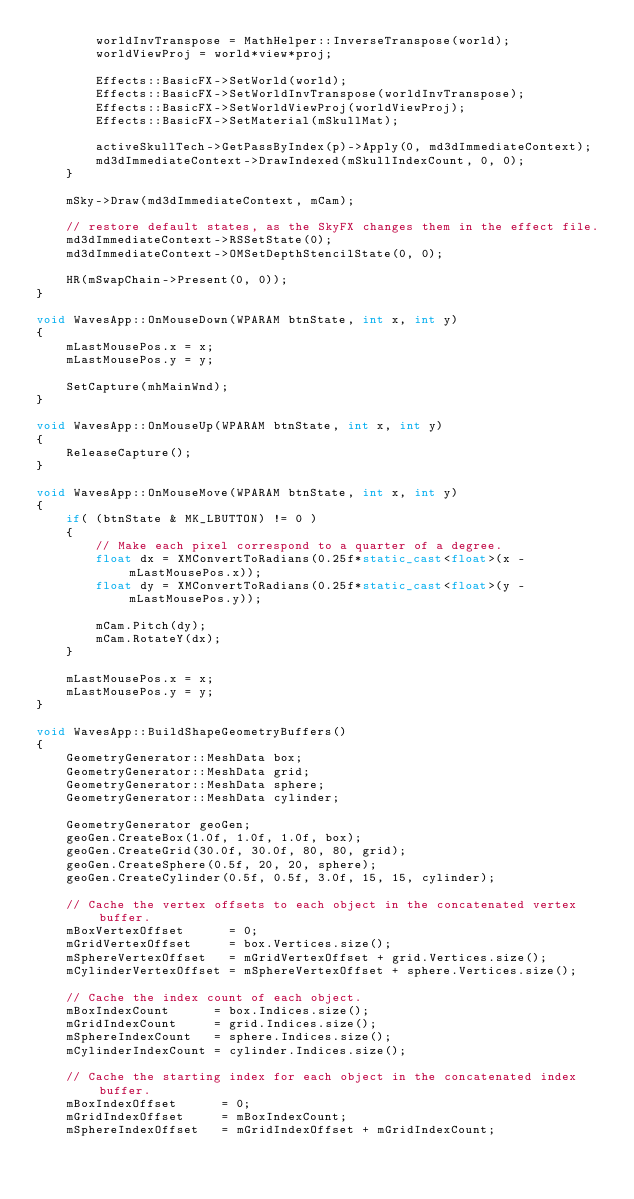<code> <loc_0><loc_0><loc_500><loc_500><_C++_>		worldInvTranspose = MathHelper::InverseTranspose(world);
		worldViewProj = world*view*proj;

		Effects::BasicFX->SetWorld(world);
		Effects::BasicFX->SetWorldInvTranspose(worldInvTranspose);
		Effects::BasicFX->SetWorldViewProj(worldViewProj);
		Effects::BasicFX->SetMaterial(mSkullMat);

		activeSkullTech->GetPassByIndex(p)->Apply(0, md3dImmediateContext);
		md3dImmediateContext->DrawIndexed(mSkullIndexCount, 0, 0);
	}

	mSky->Draw(md3dImmediateContext, mCam);

	// restore default states, as the SkyFX changes them in the effect file.
	md3dImmediateContext->RSSetState(0);
	md3dImmediateContext->OMSetDepthStencilState(0, 0);

	HR(mSwapChain->Present(0, 0));
}

void WavesApp::OnMouseDown(WPARAM btnState, int x, int y)
{
	mLastMousePos.x = x;
	mLastMousePos.y = y;

	SetCapture(mhMainWnd);
}

void WavesApp::OnMouseUp(WPARAM btnState, int x, int y)
{
	ReleaseCapture();
}

void WavesApp::OnMouseMove(WPARAM btnState, int x, int y)
{
	if( (btnState & MK_LBUTTON) != 0 )
	{
		// Make each pixel correspond to a quarter of a degree.
		float dx = XMConvertToRadians(0.25f*static_cast<float>(x - mLastMousePos.x));
		float dy = XMConvertToRadians(0.25f*static_cast<float>(y - mLastMousePos.y));

		mCam.Pitch(dy);
		mCam.RotateY(dx);
	}

	mLastMousePos.x = x;
	mLastMousePos.y = y;
}

void WavesApp::BuildShapeGeometryBuffers()
{
	GeometryGenerator::MeshData box;
	GeometryGenerator::MeshData grid;
	GeometryGenerator::MeshData sphere;
	GeometryGenerator::MeshData cylinder;

	GeometryGenerator geoGen;
	geoGen.CreateBox(1.0f, 1.0f, 1.0f, box);
	geoGen.CreateGrid(30.0f, 30.0f, 80, 80, grid);
	geoGen.CreateSphere(0.5f, 20, 20, sphere);
	geoGen.CreateCylinder(0.5f, 0.5f, 3.0f, 15, 15, cylinder);

	// Cache the vertex offsets to each object in the concatenated vertex buffer.
	mBoxVertexOffset      = 0;
	mGridVertexOffset     = box.Vertices.size();
	mSphereVertexOffset   = mGridVertexOffset + grid.Vertices.size();
	mCylinderVertexOffset = mSphereVertexOffset + sphere.Vertices.size();

	// Cache the index count of each object.
	mBoxIndexCount      = box.Indices.size();
	mGridIndexCount     = grid.Indices.size();
	mSphereIndexCount   = sphere.Indices.size();
	mCylinderIndexCount = cylinder.Indices.size();

	// Cache the starting index for each object in the concatenated index buffer.
	mBoxIndexOffset      = 0;
	mGridIndexOffset     = mBoxIndexCount;
	mSphereIndexOffset   = mGridIndexOffset + mGridIndexCount;</code> 